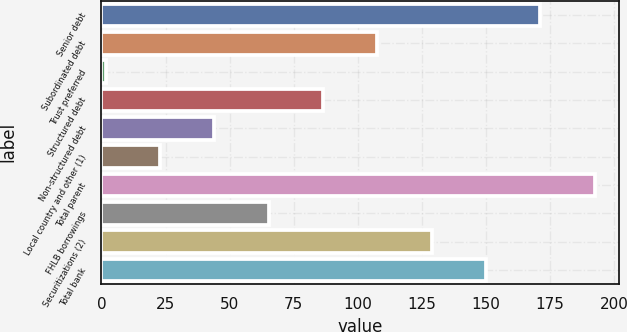Convert chart. <chart><loc_0><loc_0><loc_500><loc_500><bar_chart><fcel>Senior debt<fcel>Subordinated debt<fcel>Trust preferred<fcel>Structured debt<fcel>Non-structured debt<fcel>Local country and other (1)<fcel>Total parent<fcel>FHLB borrowings<fcel>Securitizations (2)<fcel>Total bank<nl><fcel>171.14<fcel>107.6<fcel>1.7<fcel>86.42<fcel>44.06<fcel>22.88<fcel>192.32<fcel>65.24<fcel>128.78<fcel>149.96<nl></chart> 